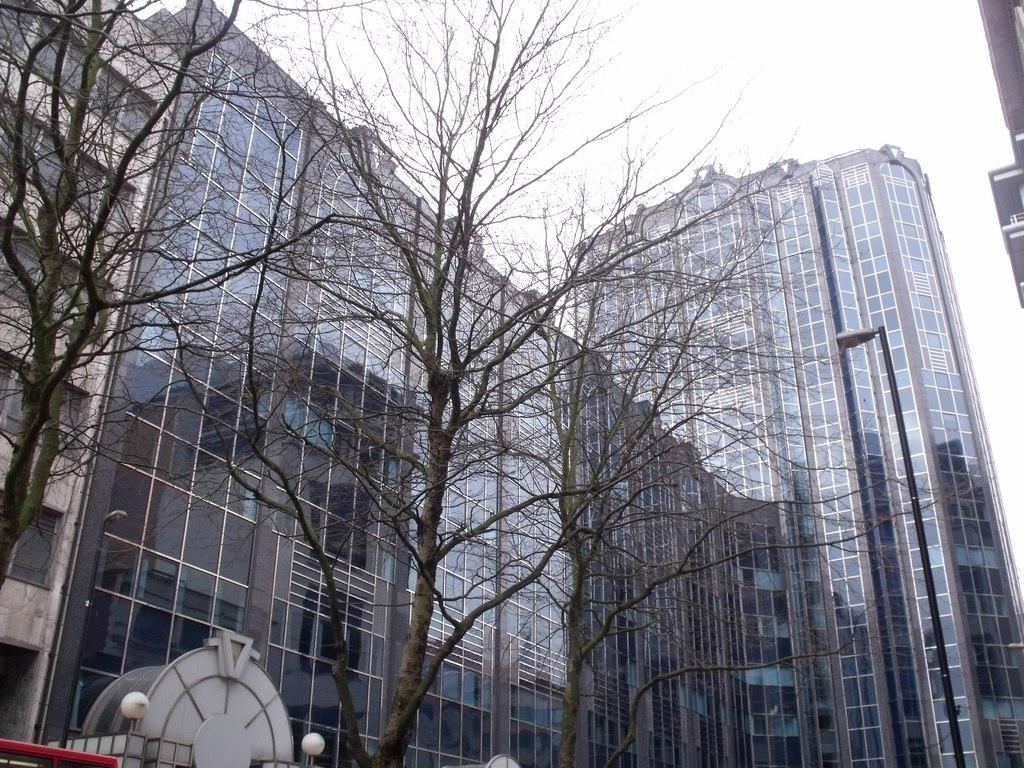What type of vegetation can be seen in the image? There are dried trees in the image. What can be seen in the distance behind the trees? There are buildings visible in the background of the image. What is the color of the sky in the image? The sky is white in color. What type of curve can be seen on the branch of the tree in the image? There are no branches visible in the image, as the trees are dried and appear to be without leaves or branches. 